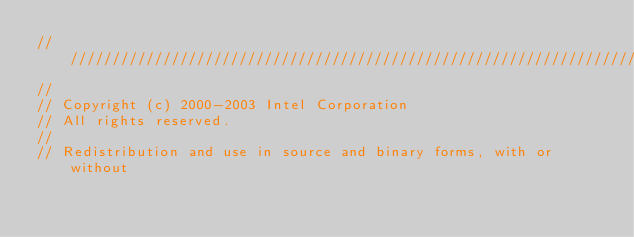<code> <loc_0><loc_0><loc_500><loc_500><_C_>///////////////////////////////////////////////////////////////////////////
//
// Copyright (c) 2000-2003 Intel Corporation 
// All rights reserved. 
//
// Redistribution and use in source and binary forms, with or without </code> 